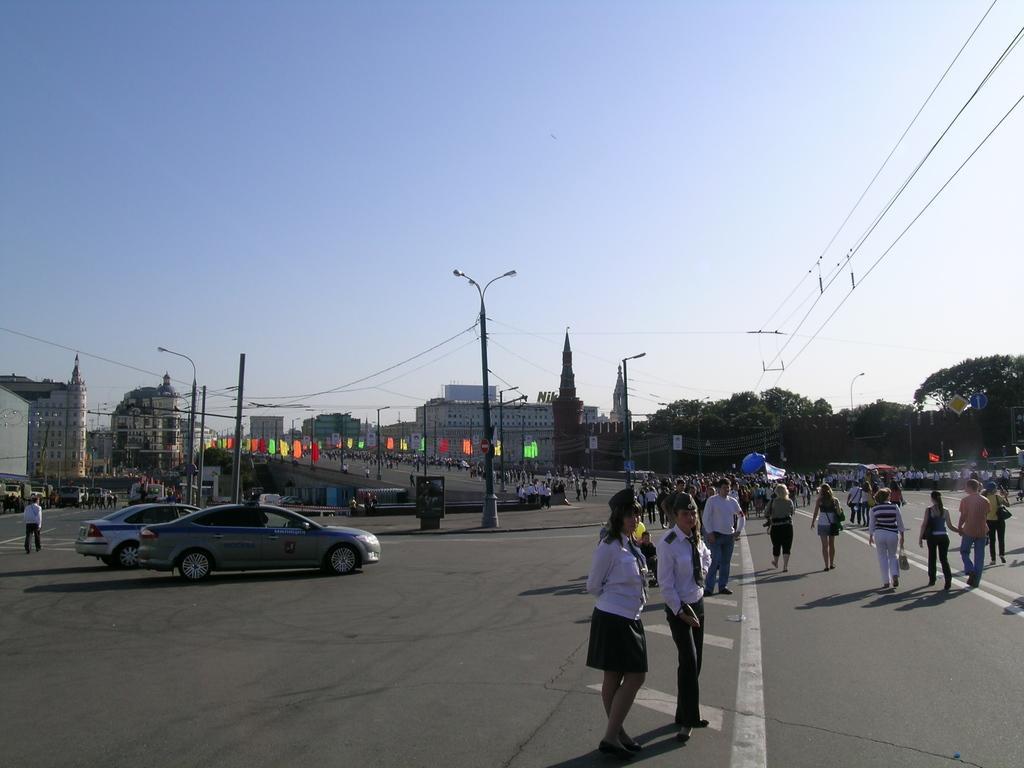Describe this image in one or two sentences. In this image we can see a group of people walking on the road. We can also see some vehicles, boards, trees, buildings, street poles, wires and the sky which looks cloudy. 